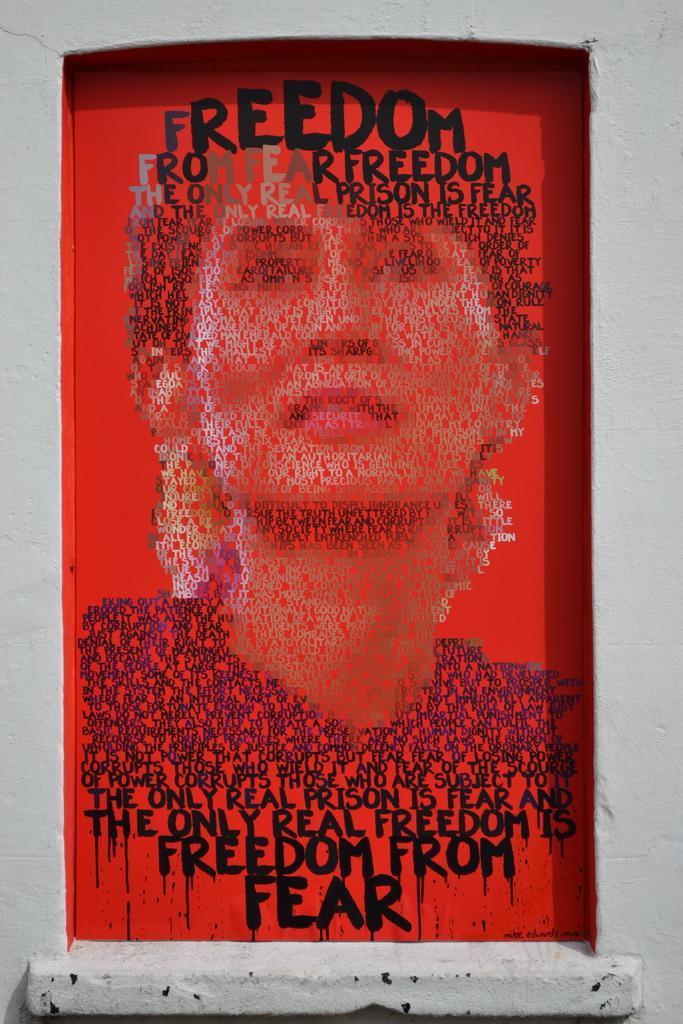In one or two sentences, can you explain what this image depicts? In this image, we can see a beautiful painting where there is a person and also some text written on it and the background of this painting is red in color. 